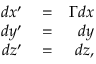<formula> <loc_0><loc_0><loc_500><loc_500>\begin{array} { r l r } { d x ^ { \prime } } & = } & { \Gamma d x } \\ { d y ^ { \prime } } & = } & { d y } \\ { d z ^ { \prime } } & = } & { d z , } \end{array}</formula> 